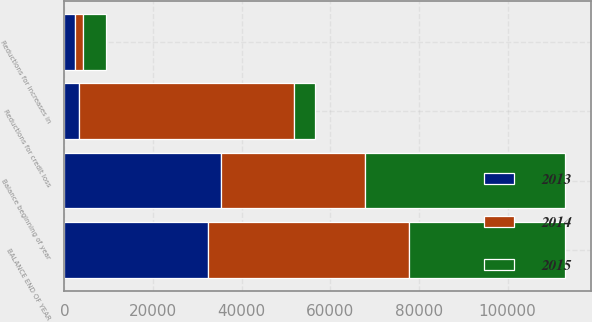Convert chart. <chart><loc_0><loc_0><loc_500><loc_500><stacked_bar_chart><ecel><fcel>Balance beginning of year<fcel>Reductions for increases in<fcel>Reductions for credit loss<fcel>BALANCE END OF YEAR<nl><fcel>2013<fcel>35424<fcel>2398<fcel>3270<fcel>32377<nl><fcel>2015<fcel>45278<fcel>5248<fcel>4636<fcel>35424<nl><fcel>2014<fcel>32377<fcel>1851<fcel>48567<fcel>45278<nl></chart> 